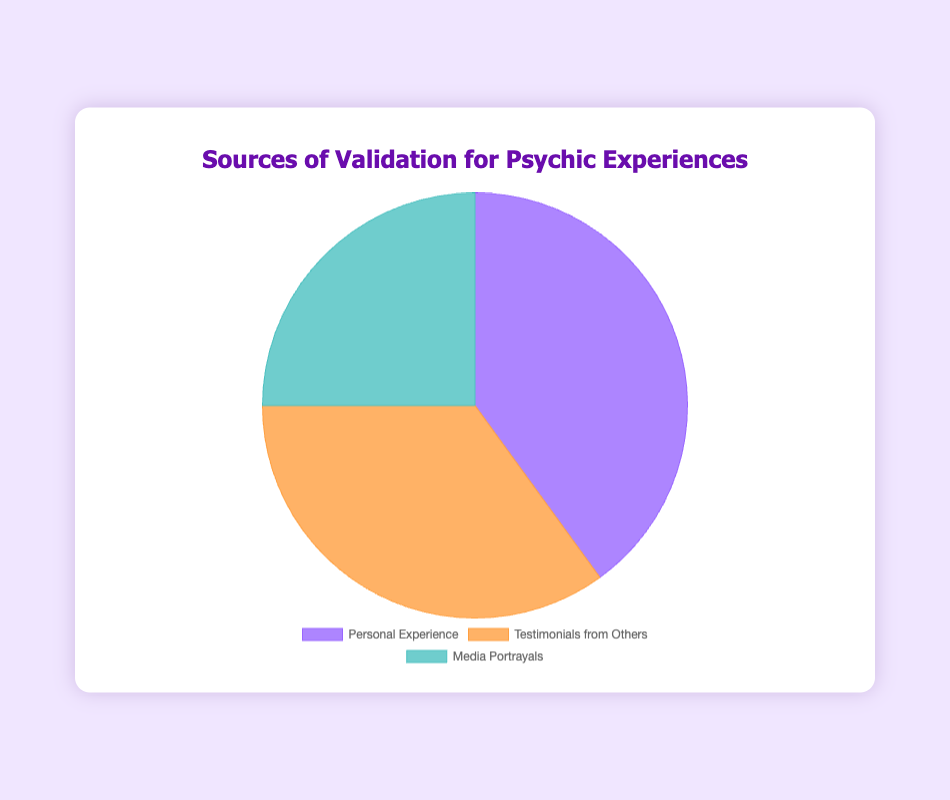What source provides validation for psychic experiences to the largest percentage of individuals? To find this, look at the segments of the pie chart and identify the one with the largest size. The label with the largest size represents "Personal Experience" with 40%.
Answer: Personal Experience Which two sources together account for more than half of the validation for psychic experiences? Add the percentages of each source and find the combination that exceeds 50%. "Personal Experience" is 40% and "Testimonials from Others" is 35%; together they sum to 75%, which is more than half.
Answer: Personal Experience and Testimonials from Others How much more validation does 'Personal Experience' provide compared to 'Media Portrayals'? Subtract the percentage of "Media Portrayals" from the percentage of "Personal Experience". 40% (Personal Experience) - 25% (Media Portrayals) = 15%.
Answer: 15% What percentage of validation comes from sources other than 'Personal Experience'? Subtract the percentage of "Personal Experience" from 100%. 100% - 40% (Personal Experience) = 60%.
Answer: 60% Combine the percentages of the two smallest sources. Does it equal or exceed the largest source? Add the percentages of "Testimonials from Others" (35%) and "Media Portrayals" (25%). Compare the sum to "Personal Experience" (40%). 35% + 25% = 60%, which is greater than 40%.
Answer: Yes Which source of validation is represented by the smallest segment on the pie chart? Find the smallest segment in the pie chart, which is labeled as "Media Portrayals" at 25%.
Answer: Media Portrayals What are the colors used for each source of validation? Look at the chart and identify the color used for each segment. "Personal Experience" is purple, "Testimonials from Others" is orange, and "Media Portrayals" is teal.
Answer: Purple: Personal Experience, Orange: Testimonials from Others, Teal: Media Portrayals If the data were represented in a bar chart instead, which bar would be the highest? Look at the values on the pie chart to determine the largest percentage, which is "Personal Experience" at 40%. This would be the highest bar in a bar chart.
Answer: Personal Experience What is the average percentage of validation provided by all sources combined? Add the percentages of all sources and divide by the number of sources. (40% + 35% + 25%) / 3 = 33.33%.
Answer: 33.33% How does the shape of the segments in the pie chart visually indicate differences in validation sources? The size and angle of each segment in the pie chart visually represent the proportion of each source. Larger segments correspond to higher percentages. "Personal Experience" has the largest segment indicating it has the highest percentage at 40%, followed by "Testimonials from Others" at 35%, and "Media Portrayals" at 25%, the smallest segment.
Answer: Larger segments correspond to higher percentages 